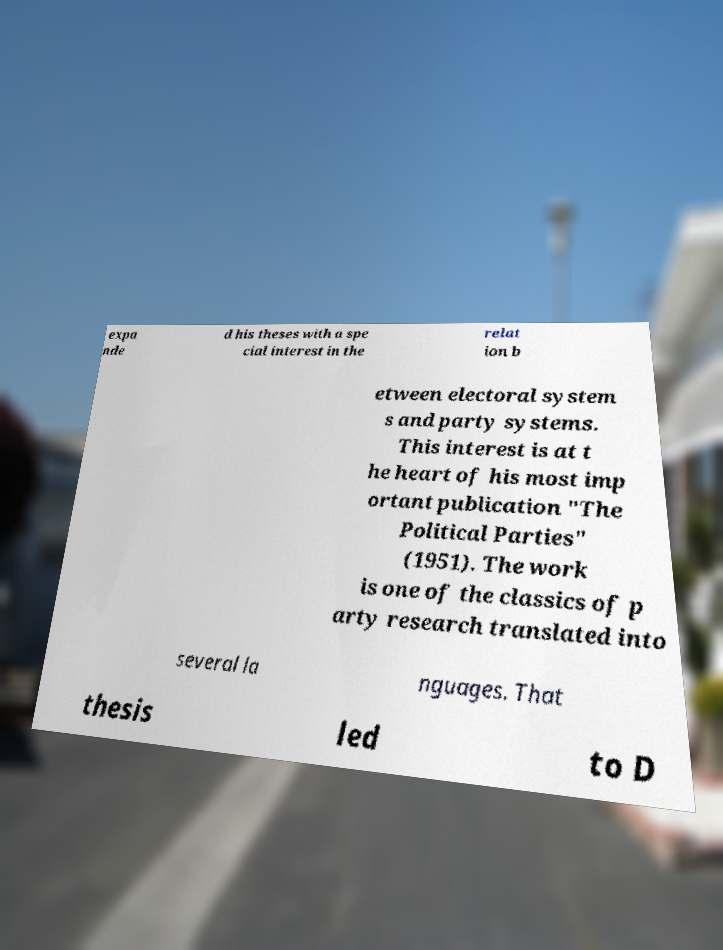I need the written content from this picture converted into text. Can you do that? expa nde d his theses with a spe cial interest in the relat ion b etween electoral system s and party systems. This interest is at t he heart of his most imp ortant publication "The Political Parties" (1951). The work is one of the classics of p arty research translated into several la nguages. That thesis led to D 